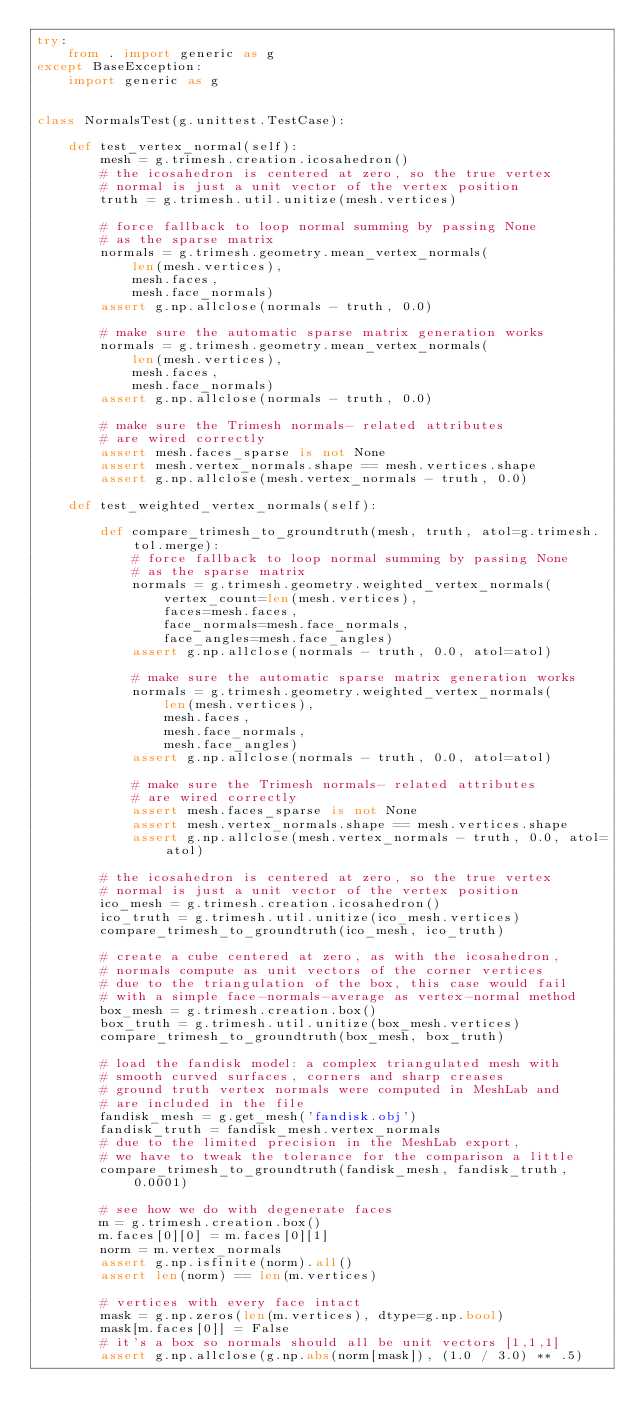Convert code to text. <code><loc_0><loc_0><loc_500><loc_500><_Python_>try:
    from . import generic as g
except BaseException:
    import generic as g


class NormalsTest(g.unittest.TestCase):

    def test_vertex_normal(self):
        mesh = g.trimesh.creation.icosahedron()
        # the icosahedron is centered at zero, so the true vertex
        # normal is just a unit vector of the vertex position
        truth = g.trimesh.util.unitize(mesh.vertices)

        # force fallback to loop normal summing by passing None
        # as the sparse matrix
        normals = g.trimesh.geometry.mean_vertex_normals(
            len(mesh.vertices),
            mesh.faces,
            mesh.face_normals)
        assert g.np.allclose(normals - truth, 0.0)

        # make sure the automatic sparse matrix generation works
        normals = g.trimesh.geometry.mean_vertex_normals(
            len(mesh.vertices),
            mesh.faces,
            mesh.face_normals)
        assert g.np.allclose(normals - truth, 0.0)

        # make sure the Trimesh normals- related attributes
        # are wired correctly
        assert mesh.faces_sparse is not None
        assert mesh.vertex_normals.shape == mesh.vertices.shape
        assert g.np.allclose(mesh.vertex_normals - truth, 0.0)

    def test_weighted_vertex_normals(self):

        def compare_trimesh_to_groundtruth(mesh, truth, atol=g.trimesh.tol.merge):
            # force fallback to loop normal summing by passing None
            # as the sparse matrix
            normals = g.trimesh.geometry.weighted_vertex_normals(
                vertex_count=len(mesh.vertices),
                faces=mesh.faces,
                face_normals=mesh.face_normals,
                face_angles=mesh.face_angles)
            assert g.np.allclose(normals - truth, 0.0, atol=atol)

            # make sure the automatic sparse matrix generation works
            normals = g.trimesh.geometry.weighted_vertex_normals(
                len(mesh.vertices),
                mesh.faces,
                mesh.face_normals,
                mesh.face_angles)
            assert g.np.allclose(normals - truth, 0.0, atol=atol)

            # make sure the Trimesh normals- related attributes
            # are wired correctly
            assert mesh.faces_sparse is not None
            assert mesh.vertex_normals.shape == mesh.vertices.shape
            assert g.np.allclose(mesh.vertex_normals - truth, 0.0, atol=atol)

        # the icosahedron is centered at zero, so the true vertex
        # normal is just a unit vector of the vertex position
        ico_mesh = g.trimesh.creation.icosahedron()
        ico_truth = g.trimesh.util.unitize(ico_mesh.vertices)
        compare_trimesh_to_groundtruth(ico_mesh, ico_truth)

        # create a cube centered at zero, as with the icosahedron,
        # normals compute as unit vectors of the corner vertices
        # due to the triangulation of the box, this case would fail
        # with a simple face-normals-average as vertex-normal method
        box_mesh = g.trimesh.creation.box()
        box_truth = g.trimesh.util.unitize(box_mesh.vertices)
        compare_trimesh_to_groundtruth(box_mesh, box_truth)

        # load the fandisk model: a complex triangulated mesh with
        # smooth curved surfaces, corners and sharp creases
        # ground truth vertex normals were computed in MeshLab and
        # are included in the file
        fandisk_mesh = g.get_mesh('fandisk.obj')
        fandisk_truth = fandisk_mesh.vertex_normals
        # due to the limited precision in the MeshLab export,
        # we have to tweak the tolerance for the comparison a little
        compare_trimesh_to_groundtruth(fandisk_mesh, fandisk_truth, 0.0001)

        # see how we do with degenerate faces
        m = g.trimesh.creation.box()
        m.faces[0][0] = m.faces[0][1]
        norm = m.vertex_normals
        assert g.np.isfinite(norm).all()
        assert len(norm) == len(m.vertices)

        # vertices with every face intact
        mask = g.np.zeros(len(m.vertices), dtype=g.np.bool)
        mask[m.faces[0]] = False
        # it's a box so normals should all be unit vectors [1,1,1]
        assert g.np.allclose(g.np.abs(norm[mask]), (1.0 / 3.0) ** .5)
</code> 